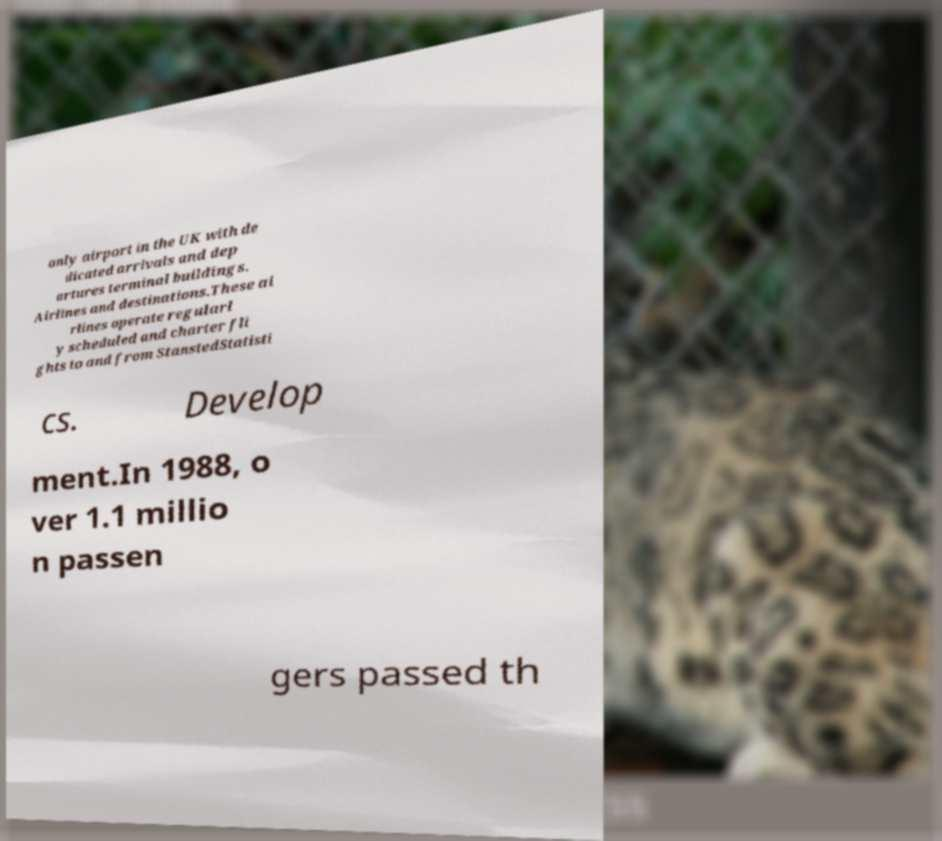Please identify and transcribe the text found in this image. only airport in the UK with de dicated arrivals and dep artures terminal buildings. Airlines and destinations.These ai rlines operate regularl y scheduled and charter fli ghts to and from StanstedStatisti cs. Develop ment.In 1988, o ver 1.1 millio n passen gers passed th 